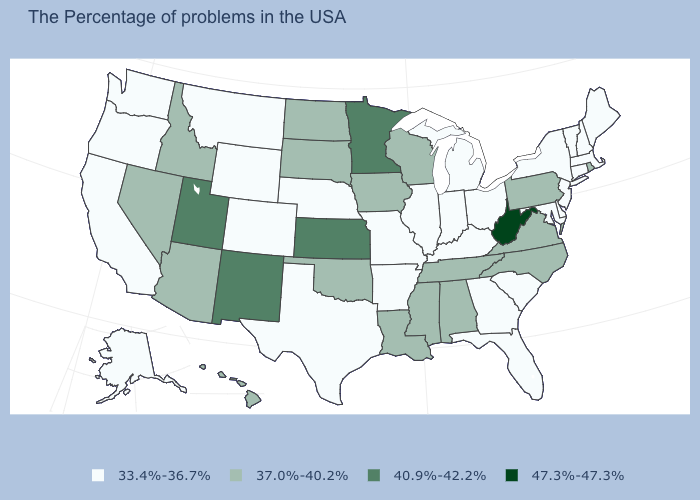Is the legend a continuous bar?
Write a very short answer. No. What is the highest value in the USA?
Short answer required. 47.3%-47.3%. Is the legend a continuous bar?
Answer briefly. No. How many symbols are there in the legend?
Concise answer only. 4. Is the legend a continuous bar?
Answer briefly. No. Which states have the lowest value in the USA?
Give a very brief answer. Maine, Massachusetts, New Hampshire, Vermont, Connecticut, New York, New Jersey, Delaware, Maryland, South Carolina, Ohio, Florida, Georgia, Michigan, Kentucky, Indiana, Illinois, Missouri, Arkansas, Nebraska, Texas, Wyoming, Colorado, Montana, California, Washington, Oregon, Alaska. Does the first symbol in the legend represent the smallest category?
Quick response, please. Yes. Does the first symbol in the legend represent the smallest category?
Be succinct. Yes. How many symbols are there in the legend?
Give a very brief answer. 4. Does Florida have a higher value than Idaho?
Short answer required. No. Does Nebraska have a lower value than New Hampshire?
Short answer required. No. What is the lowest value in the Northeast?
Write a very short answer. 33.4%-36.7%. Does Delaware have the highest value in the South?
Quick response, please. No. What is the value of Nevada?
Quick response, please. 37.0%-40.2%. Name the states that have a value in the range 47.3%-47.3%?
Concise answer only. West Virginia. 